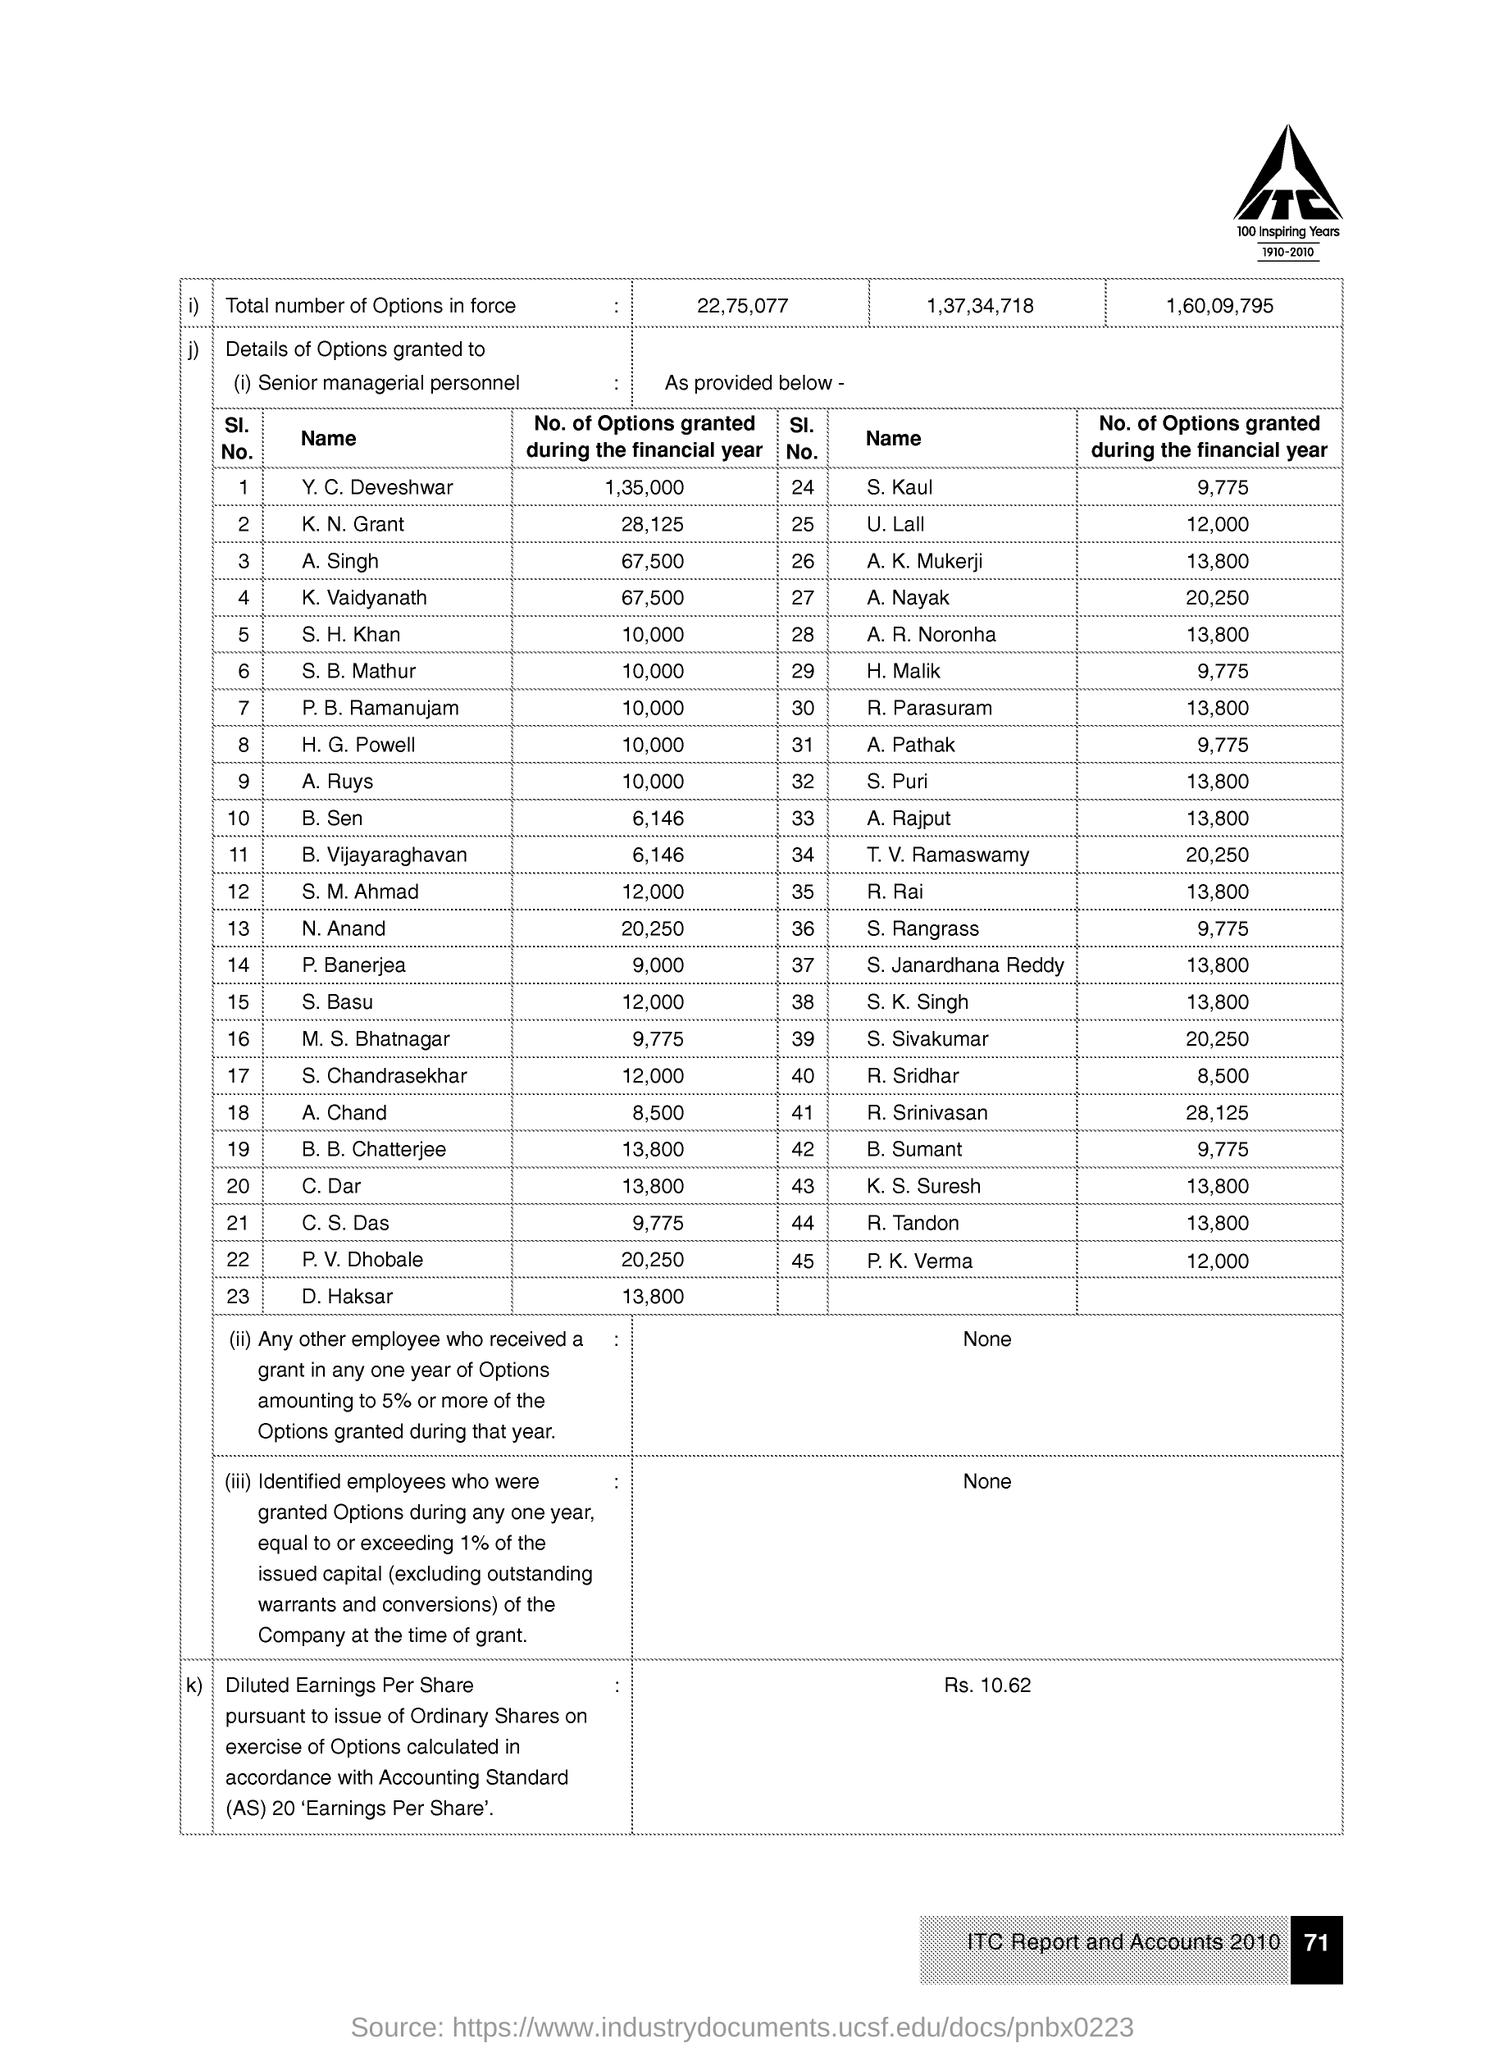What is written within the company logo in bold letters?
Your response must be concise. ITC. Which "100 Inspiring Years" is mentioned under the logo?
Give a very brief answer. 1910-2010. What is the page number given at the right bottom corner of the page?
Offer a very short reply. 71. Mention the "No. of Options granted dring the financial year" for "Y.C. Deveshwar"?
Make the answer very short. 1,35,000. Mention the "No. of Options granted dring the financial year" for "C. Dar"?
Give a very brief answer. 13,800. Mention the "No. of Options granted dring the financial year" for "R. Rai"?
Keep it short and to the point. 13,800. What is the "Sl. No." of H.G.Powell?
Offer a very short reply. 8. What is the "Sl. No." of P.K. Verma?
Your response must be concise. 45. Mention the "No. of Options granted dring the financial year" for "M. S. Bhatnagar"?
Provide a succinct answer. 9,775. What is the "Sl. No." of S.Kaul?
Ensure brevity in your answer.  24. 